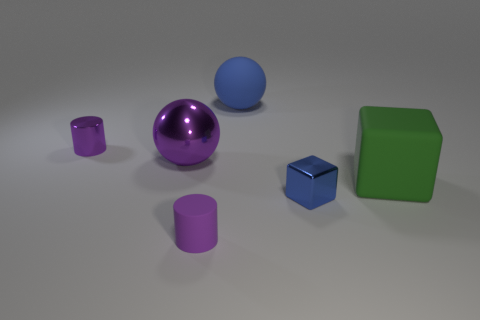What is the size of the rubber cylinder that is the same color as the large shiny sphere?
Keep it short and to the point. Small. Do the large green rubber object and the blue metal thing have the same shape?
Provide a succinct answer. Yes. There is another object that is the same shape as the large green object; what is its material?
Offer a terse response. Metal. Is the color of the small cylinder behind the blue shiny block the same as the big metal sphere?
Make the answer very short. Yes. Is the material of the purple cylinder behind the purple rubber cylinder the same as the tiny blue cube in front of the small purple shiny cylinder?
Your answer should be very brief. Yes. What material is the big blue thing?
Make the answer very short. Rubber. How many blue metallic objects have the same shape as the large green thing?
Provide a short and direct response. 1. There is a cube that is the same color as the rubber sphere; what is it made of?
Your response must be concise. Metal. The tiny metal object that is to the left of the blue matte ball that is right of the rubber thing that is in front of the green matte block is what color?
Keep it short and to the point. Purple. How many large objects are either cylinders or yellow metal objects?
Ensure brevity in your answer.  0. 